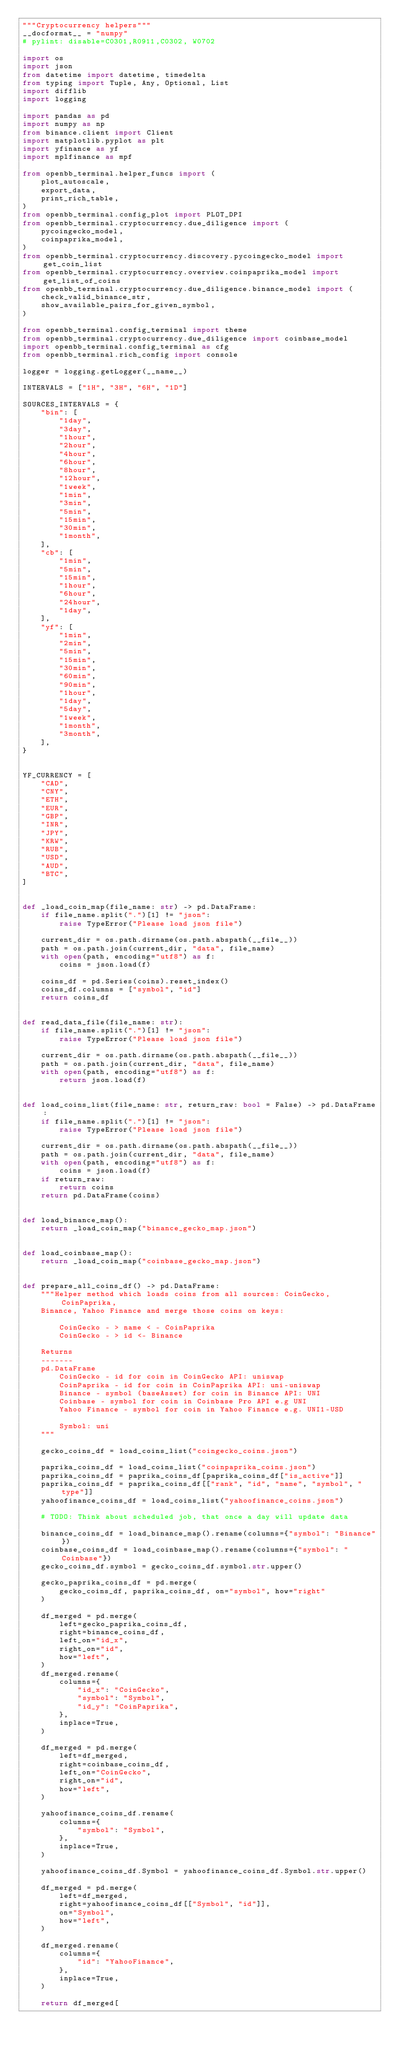Convert code to text. <code><loc_0><loc_0><loc_500><loc_500><_Python_>"""Cryptocurrency helpers"""
__docformat__ = "numpy"
# pylint: disable=C0301,R0911,C0302, W0702

import os
import json
from datetime import datetime, timedelta
from typing import Tuple, Any, Optional, List
import difflib
import logging

import pandas as pd
import numpy as np
from binance.client import Client
import matplotlib.pyplot as plt
import yfinance as yf
import mplfinance as mpf

from openbb_terminal.helper_funcs import (
    plot_autoscale,
    export_data,
    print_rich_table,
)
from openbb_terminal.config_plot import PLOT_DPI
from openbb_terminal.cryptocurrency.due_diligence import (
    pycoingecko_model,
    coinpaprika_model,
)
from openbb_terminal.cryptocurrency.discovery.pycoingecko_model import get_coin_list
from openbb_terminal.cryptocurrency.overview.coinpaprika_model import get_list_of_coins
from openbb_terminal.cryptocurrency.due_diligence.binance_model import (
    check_valid_binance_str,
    show_available_pairs_for_given_symbol,
)

from openbb_terminal.config_terminal import theme
from openbb_terminal.cryptocurrency.due_diligence import coinbase_model
import openbb_terminal.config_terminal as cfg
from openbb_terminal.rich_config import console

logger = logging.getLogger(__name__)

INTERVALS = ["1H", "3H", "6H", "1D"]

SOURCES_INTERVALS = {
    "bin": [
        "1day",
        "3day",
        "1hour",
        "2hour",
        "4hour",
        "6hour",
        "8hour",
        "12hour",
        "1week",
        "1min",
        "3min",
        "5min",
        "15min",
        "30min",
        "1month",
    ],
    "cb": [
        "1min",
        "5min",
        "15min",
        "1hour",
        "6hour",
        "24hour",
        "1day",
    ],
    "yf": [
        "1min",
        "2min",
        "5min",
        "15min",
        "30min",
        "60min",
        "90min",
        "1hour",
        "1day",
        "5day",
        "1week",
        "1month",
        "3month",
    ],
}


YF_CURRENCY = [
    "CAD",
    "CNY",
    "ETH",
    "EUR",
    "GBP",
    "INR",
    "JPY",
    "KRW",
    "RUB",
    "USD",
    "AUD",
    "BTC",
]


def _load_coin_map(file_name: str) -> pd.DataFrame:
    if file_name.split(".")[1] != "json":
        raise TypeError("Please load json file")

    current_dir = os.path.dirname(os.path.abspath(__file__))
    path = os.path.join(current_dir, "data", file_name)
    with open(path, encoding="utf8") as f:
        coins = json.load(f)

    coins_df = pd.Series(coins).reset_index()
    coins_df.columns = ["symbol", "id"]
    return coins_df


def read_data_file(file_name: str):
    if file_name.split(".")[1] != "json":
        raise TypeError("Please load json file")

    current_dir = os.path.dirname(os.path.abspath(__file__))
    path = os.path.join(current_dir, "data", file_name)
    with open(path, encoding="utf8") as f:
        return json.load(f)


def load_coins_list(file_name: str, return_raw: bool = False) -> pd.DataFrame:
    if file_name.split(".")[1] != "json":
        raise TypeError("Please load json file")

    current_dir = os.path.dirname(os.path.abspath(__file__))
    path = os.path.join(current_dir, "data", file_name)
    with open(path, encoding="utf8") as f:
        coins = json.load(f)
    if return_raw:
        return coins
    return pd.DataFrame(coins)


def load_binance_map():
    return _load_coin_map("binance_gecko_map.json")


def load_coinbase_map():
    return _load_coin_map("coinbase_gecko_map.json")


def prepare_all_coins_df() -> pd.DataFrame:
    """Helper method which loads coins from all sources: CoinGecko, CoinPaprika,
    Binance, Yahoo Finance and merge those coins on keys:

        CoinGecko - > name < - CoinPaprika
        CoinGecko - > id <- Binance

    Returns
    -------
    pd.DataFrame
        CoinGecko - id for coin in CoinGecko API: uniswap
        CoinPaprika - id for coin in CoinPaprika API: uni-uniswap
        Binance - symbol (baseAsset) for coin in Binance API: UNI
        Coinbase - symbol for coin in Coinbase Pro API e.g UNI
        Yahoo Finance - symbol for coin in Yahoo Finance e.g. UNI1-USD

        Symbol: uni
    """

    gecko_coins_df = load_coins_list("coingecko_coins.json")

    paprika_coins_df = load_coins_list("coinpaprika_coins.json")
    paprika_coins_df = paprika_coins_df[paprika_coins_df["is_active"]]
    paprika_coins_df = paprika_coins_df[["rank", "id", "name", "symbol", "type"]]
    yahoofinance_coins_df = load_coins_list("yahoofinance_coins.json")

    # TODO: Think about scheduled job, that once a day will update data

    binance_coins_df = load_binance_map().rename(columns={"symbol": "Binance"})
    coinbase_coins_df = load_coinbase_map().rename(columns={"symbol": "Coinbase"})
    gecko_coins_df.symbol = gecko_coins_df.symbol.str.upper()

    gecko_paprika_coins_df = pd.merge(
        gecko_coins_df, paprika_coins_df, on="symbol", how="right"
    )

    df_merged = pd.merge(
        left=gecko_paprika_coins_df,
        right=binance_coins_df,
        left_on="id_x",
        right_on="id",
        how="left",
    )
    df_merged.rename(
        columns={
            "id_x": "CoinGecko",
            "symbol": "Symbol",
            "id_y": "CoinPaprika",
        },
        inplace=True,
    )

    df_merged = pd.merge(
        left=df_merged,
        right=coinbase_coins_df,
        left_on="CoinGecko",
        right_on="id",
        how="left",
    )

    yahoofinance_coins_df.rename(
        columns={
            "symbol": "Symbol",
        },
        inplace=True,
    )

    yahoofinance_coins_df.Symbol = yahoofinance_coins_df.Symbol.str.upper()

    df_merged = pd.merge(
        left=df_merged,
        right=yahoofinance_coins_df[["Symbol", "id"]],
        on="Symbol",
        how="left",
    )

    df_merged.rename(
        columns={
            "id": "YahooFinance",
        },
        inplace=True,
    )

    return df_merged[</code> 